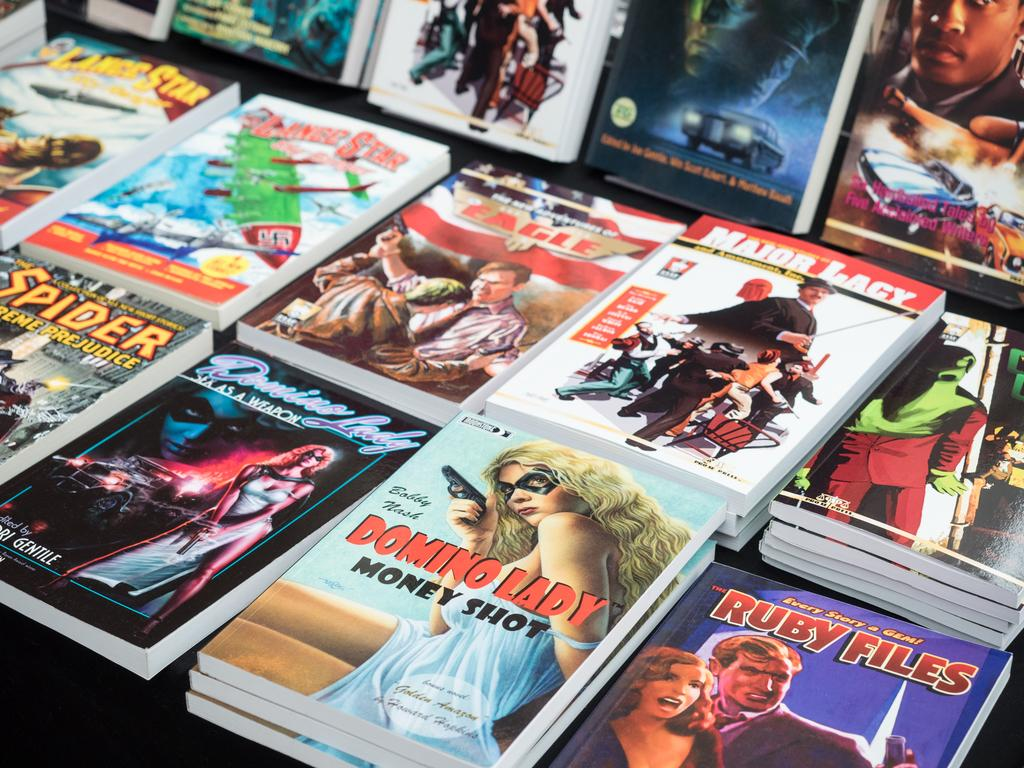Provide a one-sentence caption for the provided image. Several books being displayed on a table, one of which is Domino Lady. 